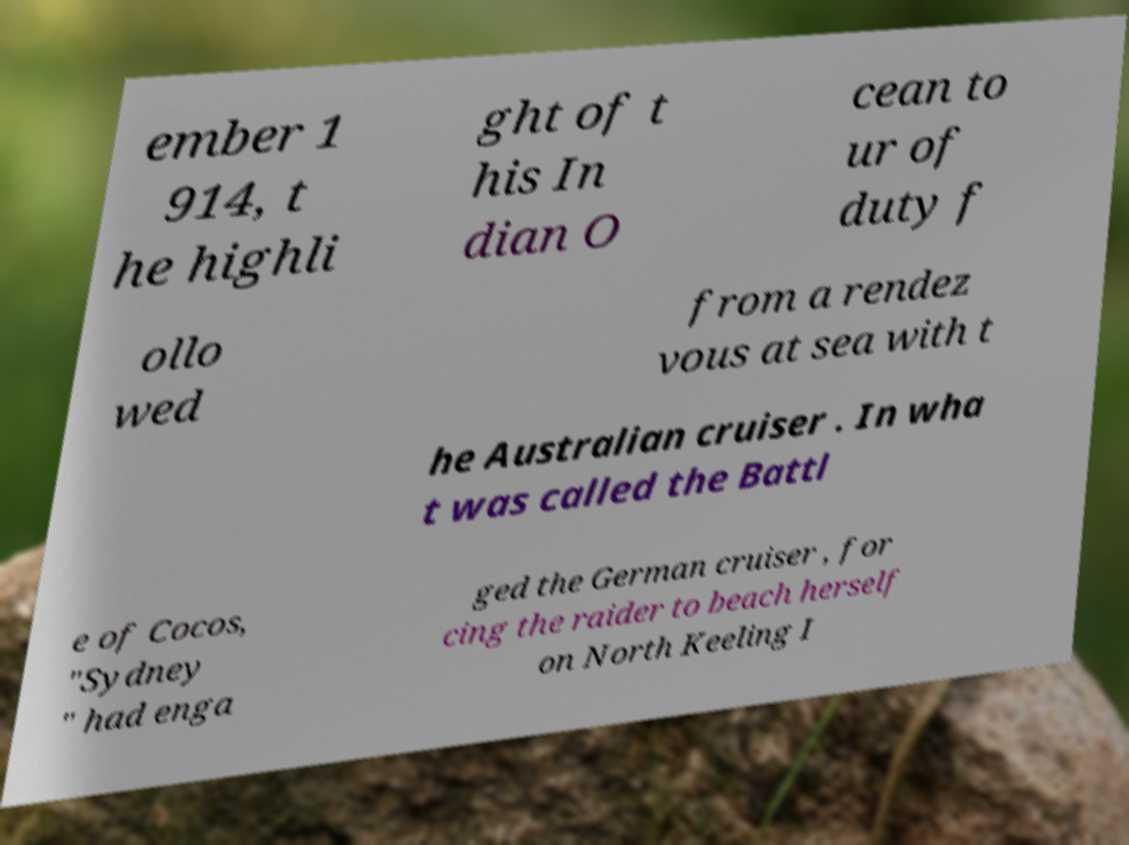For documentation purposes, I need the text within this image transcribed. Could you provide that? ember 1 914, t he highli ght of t his In dian O cean to ur of duty f ollo wed from a rendez vous at sea with t he Australian cruiser . In wha t was called the Battl e of Cocos, "Sydney " had enga ged the German cruiser , for cing the raider to beach herself on North Keeling I 